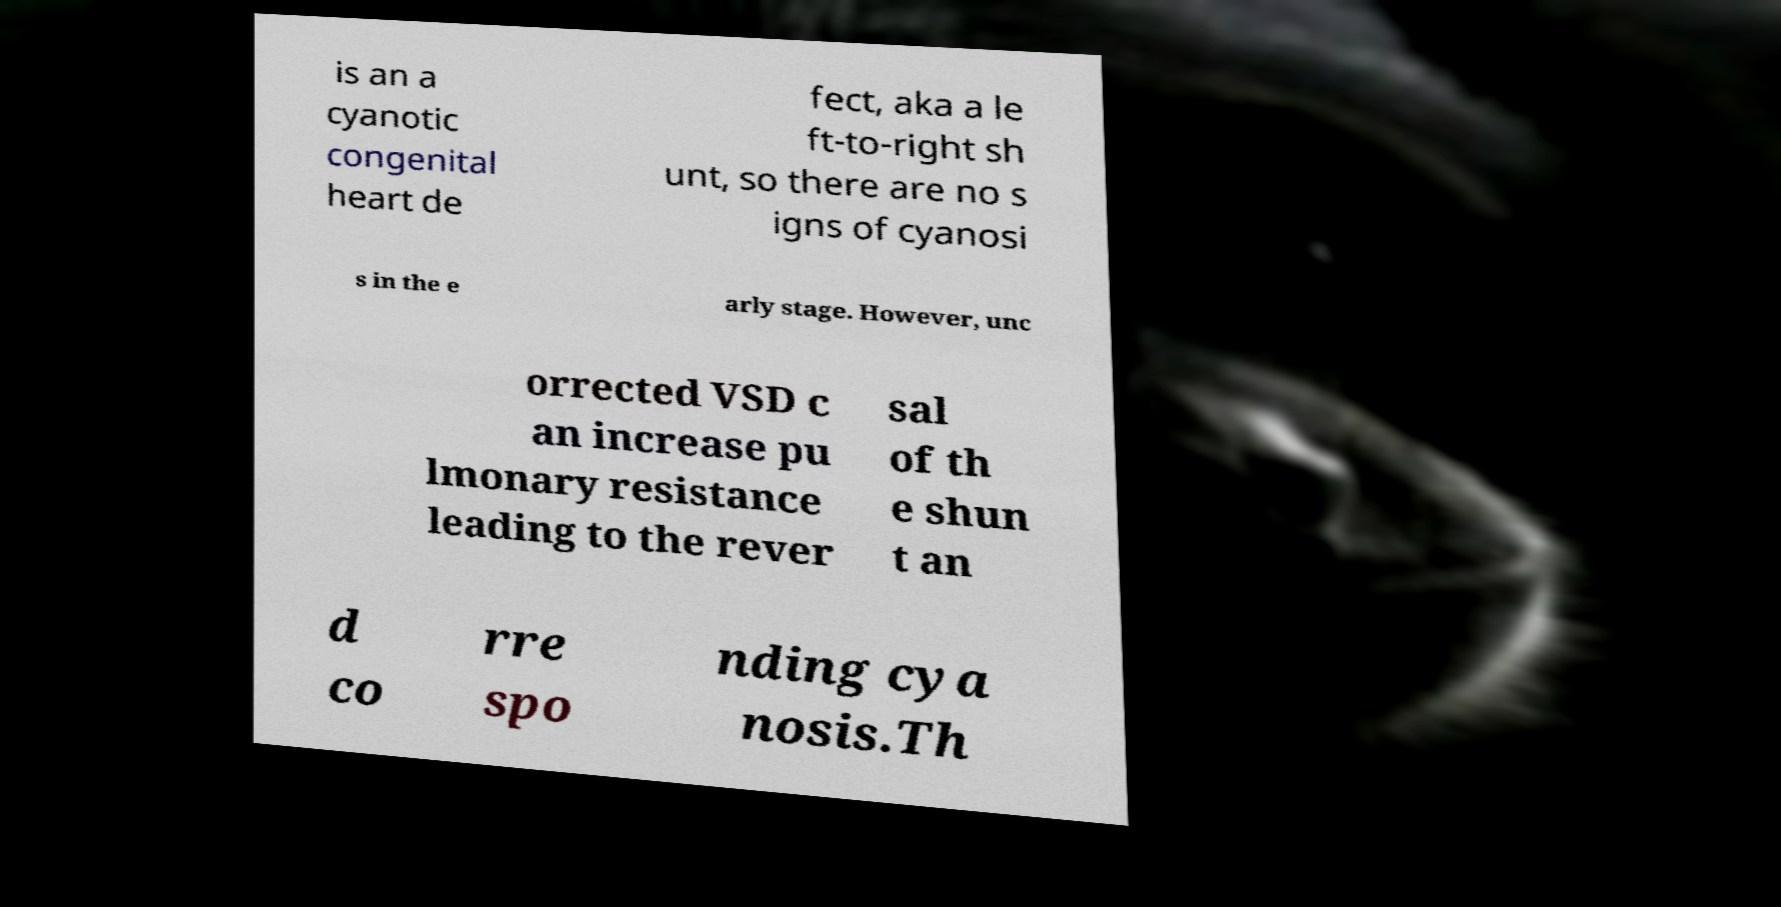For documentation purposes, I need the text within this image transcribed. Could you provide that? is an a cyanotic congenital heart de fect, aka a le ft-to-right sh unt, so there are no s igns of cyanosi s in the e arly stage. However, unc orrected VSD c an increase pu lmonary resistance leading to the rever sal of th e shun t an d co rre spo nding cya nosis.Th 